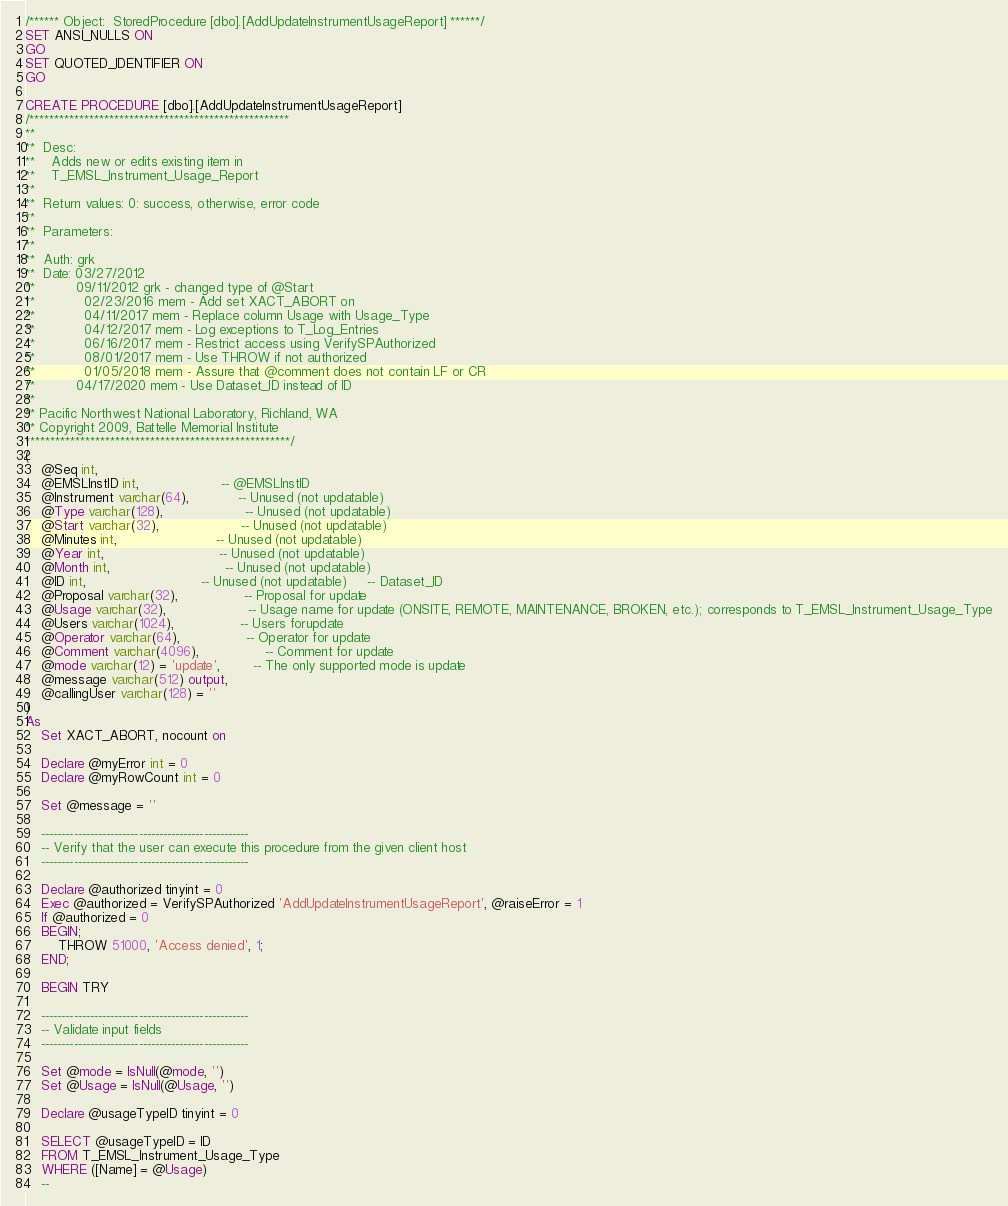Convert code to text. <code><loc_0><loc_0><loc_500><loc_500><_SQL_>/****** Object:  StoredProcedure [dbo].[AddUpdateInstrumentUsageReport] ******/
SET ANSI_NULLS ON
GO
SET QUOTED_IDENTIFIER ON
GO

CREATE PROCEDURE [dbo].[AddUpdateInstrumentUsageReport]
/****************************************************
**
**  Desc: 
**    Adds new or edits existing item in 
**    T_EMSL_Instrument_Usage_Report 
**
**  Return values: 0: success, otherwise, error code
**
**  Parameters:
**
**  Auth:	grk
**  Date:	03/27/2012 
**          09/11/2012 grk - changed type of @Start
**			02/23/2016 mem - Add set XACT_ABORT on
**			04/11/2017 mem - Replace column Usage with Usage_Type
**			04/12/2017 mem - Log exceptions to T_Log_Entries
**			06/16/2017 mem - Restrict access using VerifySPAuthorized
**			08/01/2017 mem - Use THROW if not authorized
**			01/05/2018 mem - Assure that @comment does not contain LF or CR
**          04/17/2020 mem - Use Dataset_ID instead of ID
**    
** Pacific Northwest National Laboratory, Richland, WA
** Copyright 2009, Battelle Memorial Institute
*****************************************************/
(
	@Seq int,
	@EMSLInstID int,					-- @EMSLInstID
	@Instrument varchar(64),			-- Unused (not updatable)
	@Type varchar(128),					-- Unused (not updatable)
	@Start varchar(32),					-- Unused (not updatable)
	@Minutes int,						-- Unused (not updatable)
	@Year int,							-- Unused (not updatable)
	@Month int,							-- Unused (not updatable)
	@ID int,							-- Unused (not updatable)     -- Dataset_ID
	@Proposal varchar(32),				-- Proposal for update
	@Usage varchar(32),					-- Usage name for update (ONSITE, REMOTE, MAINTENANCE, BROKEN, etc.); corresponds to T_EMSL_Instrument_Usage_Type
	@Users varchar(1024),				-- Users forupdate
	@Operator varchar(64),				-- Operator for update
	@Comment varchar(4096),				-- Comment for update
	@mode varchar(12) = 'update',		-- The only supported mode is update
	@message varchar(512) output,
	@callingUser varchar(128) = ''
)
As
	Set XACT_ABORT, nocount on

	Declare @myError int = 0
	Declare @myRowCount int = 0

	Set @message = ''

	---------------------------------------------------
	-- Verify that the user can execute this procedure from the given client host
	---------------------------------------------------
		
	Declare @authorized tinyint = 0	
	Exec @authorized = VerifySPAuthorized 'AddUpdateInstrumentUsageReport', @raiseError = 1
	If @authorized = 0
	BEGIN;
		THROW 51000, 'Access denied', 1;
	END;

	BEGIN TRY 

	---------------------------------------------------
	-- Validate input fields
	---------------------------------------------------

	Set @mode = IsNull(@mode, '')
	Set @Usage = IsNull(@Usage, '')
	
	Declare @usageTypeID tinyint = 0
	
	SELECT @usageTypeID = ID
	FROM T_EMSL_Instrument_Usage_Type
	WHERE ([Name] = @Usage)
	--</code> 